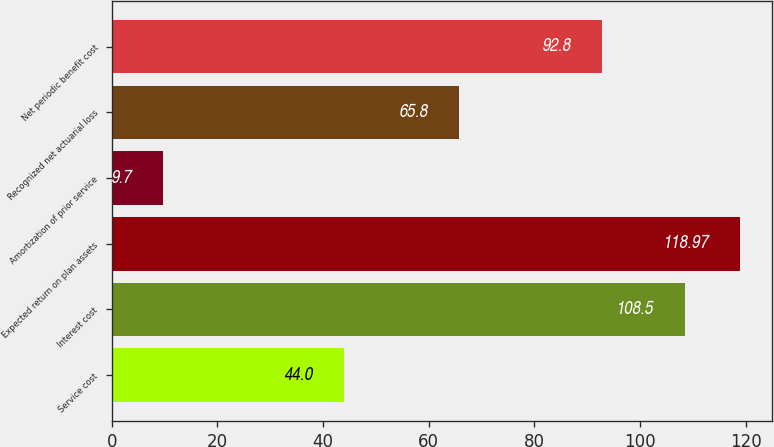Convert chart. <chart><loc_0><loc_0><loc_500><loc_500><bar_chart><fcel>Service cost<fcel>Interest cost<fcel>Expected return on plan assets<fcel>Amortization of prior service<fcel>Recognized net actuarial loss<fcel>Net periodic benefit cost<nl><fcel>44<fcel>108.5<fcel>118.97<fcel>9.7<fcel>65.8<fcel>92.8<nl></chart> 